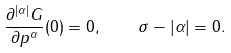Convert formula to latex. <formula><loc_0><loc_0><loc_500><loc_500>\frac { \partial ^ { | \alpha | } G } { \partial p ^ { \alpha } } ( 0 ) = 0 , \quad \sigma - | \alpha | = 0 .</formula> 